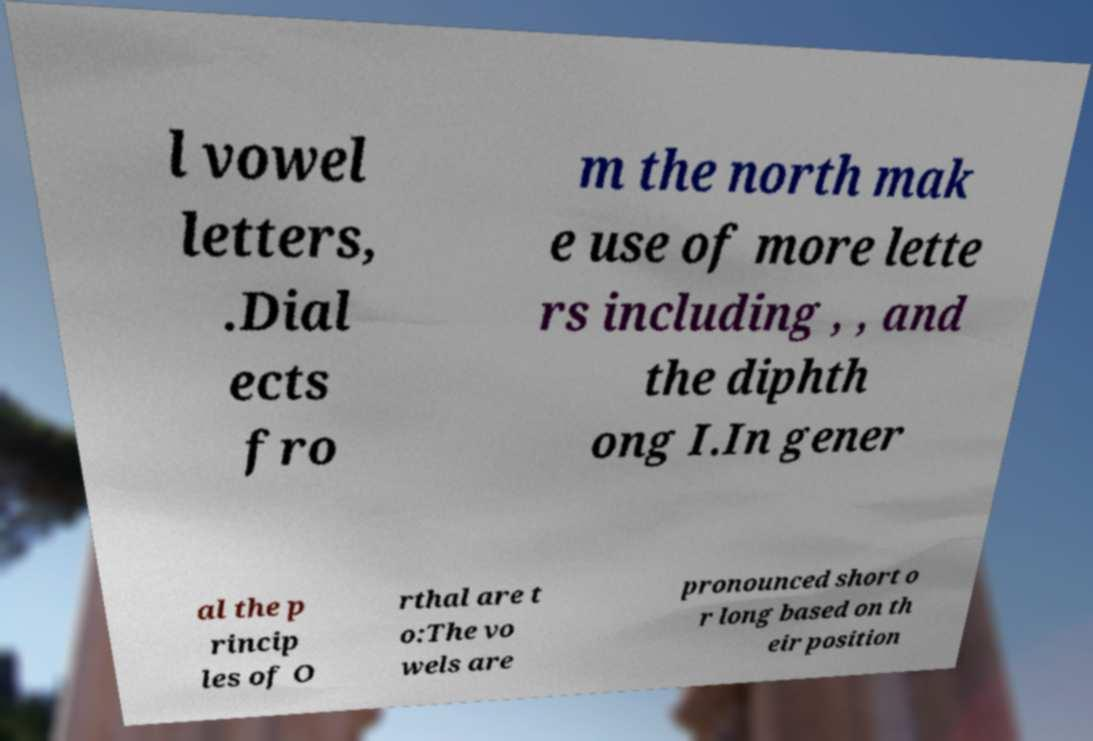I need the written content from this picture converted into text. Can you do that? l vowel letters, .Dial ects fro m the north mak e use of more lette rs including , , and the diphth ong I.In gener al the p rincip les of O rthal are t o:The vo wels are pronounced short o r long based on th eir position 